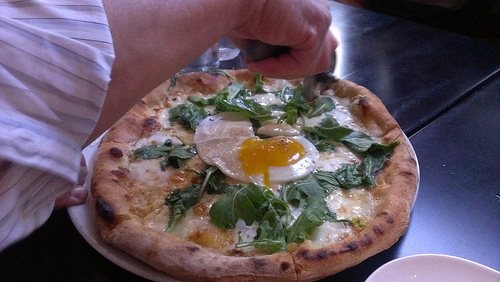Do you see any bacon to the left of the cheese on the right? No, there is no bacon to the left of the cheese on the right side. 